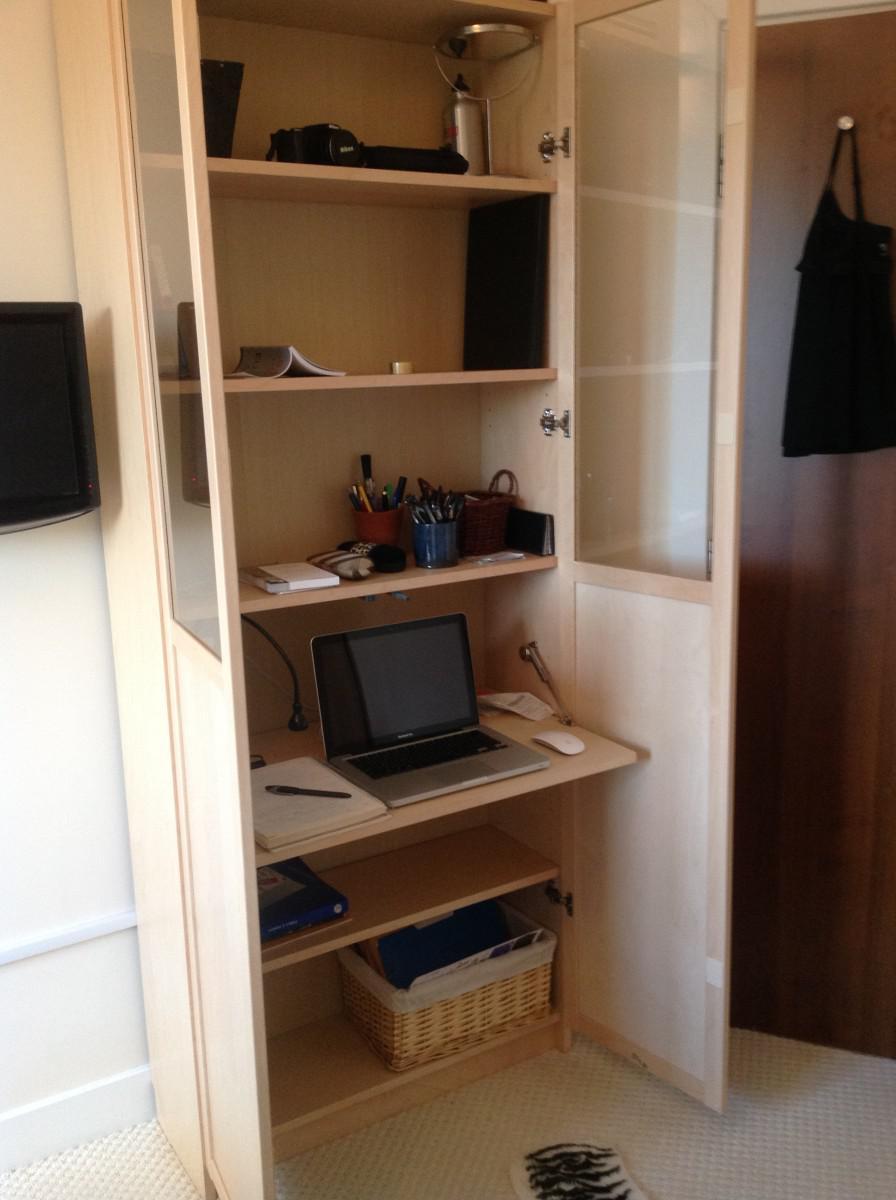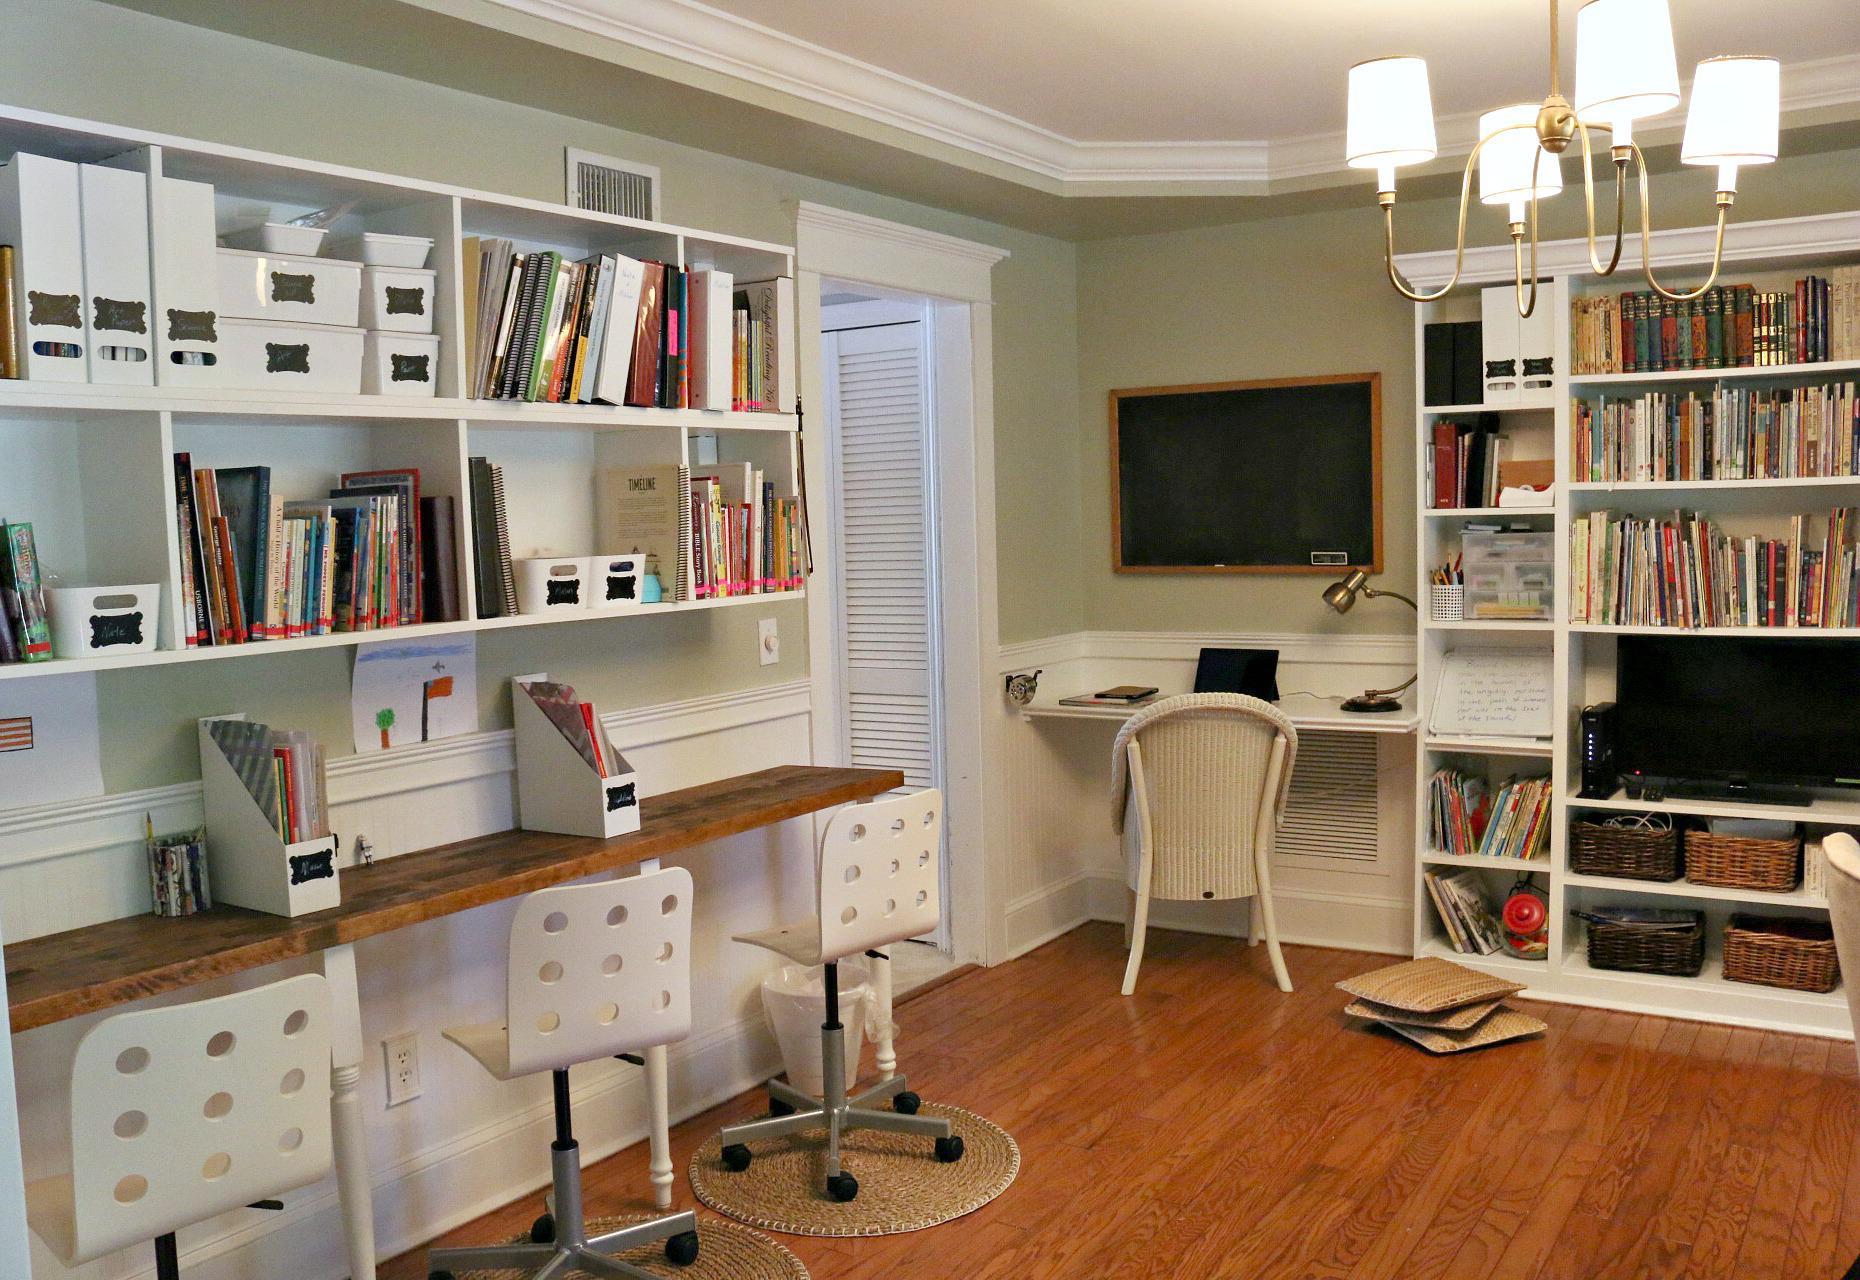The first image is the image on the left, the second image is the image on the right. For the images displayed, is the sentence "Three chairs with wheels are in front of a desk in one of the pictures." factually correct? Answer yes or no. Yes. The first image is the image on the left, the second image is the image on the right. Given the left and right images, does the statement "One of the images features a desk with three chairs." hold true? Answer yes or no. Yes. 